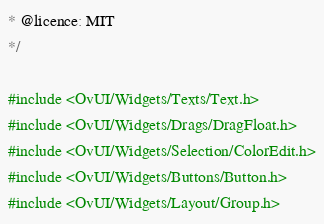<code> <loc_0><loc_0><loc_500><loc_500><_C++_>* @licence: MIT
*/

#include <OvUI/Widgets/Texts/Text.h>
#include <OvUI/Widgets/Drags/DragFloat.h>
#include <OvUI/Widgets/Selection/ColorEdit.h>
#include <OvUI/Widgets/Buttons/Button.h>
#include <OvUI/Widgets/Layout/Group.h>
</code> 